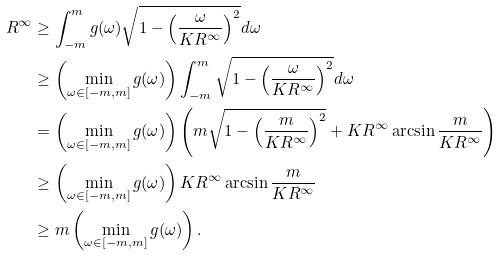<formula> <loc_0><loc_0><loc_500><loc_500>R ^ { \infty } & \geq \int _ { - m } ^ { m } g ( \omega ) \sqrt { 1 - \left ( \frac { \omega } { K R ^ { \infty } } \right ) ^ { 2 } } d \omega \\ & \geq \left ( \min _ { \omega \in [ - m , m ] } g ( \omega ) \right ) \int _ { - m } ^ { m } \sqrt { 1 - \left ( \frac { \omega } { K R ^ { \infty } } \right ) ^ { 2 } } d \omega \\ & = \left ( \min _ { \omega \in [ - m , m ] } g ( \omega ) \right ) \left ( m \sqrt { 1 - \left ( \frac { m } { K R ^ { \infty } } \right ) ^ { 2 } } + K R ^ { \infty } \arcsin \frac { m } { K R ^ { \infty } } \right ) \\ & \geq \left ( \min _ { \omega \in [ - m , m ] } g ( \omega ) \right ) K R ^ { \infty } \arcsin \frac { m } { K R ^ { \infty } } \\ & \geq m \left ( \min _ { \omega \in [ - m , m ] } g ( \omega ) \right ) .</formula> 